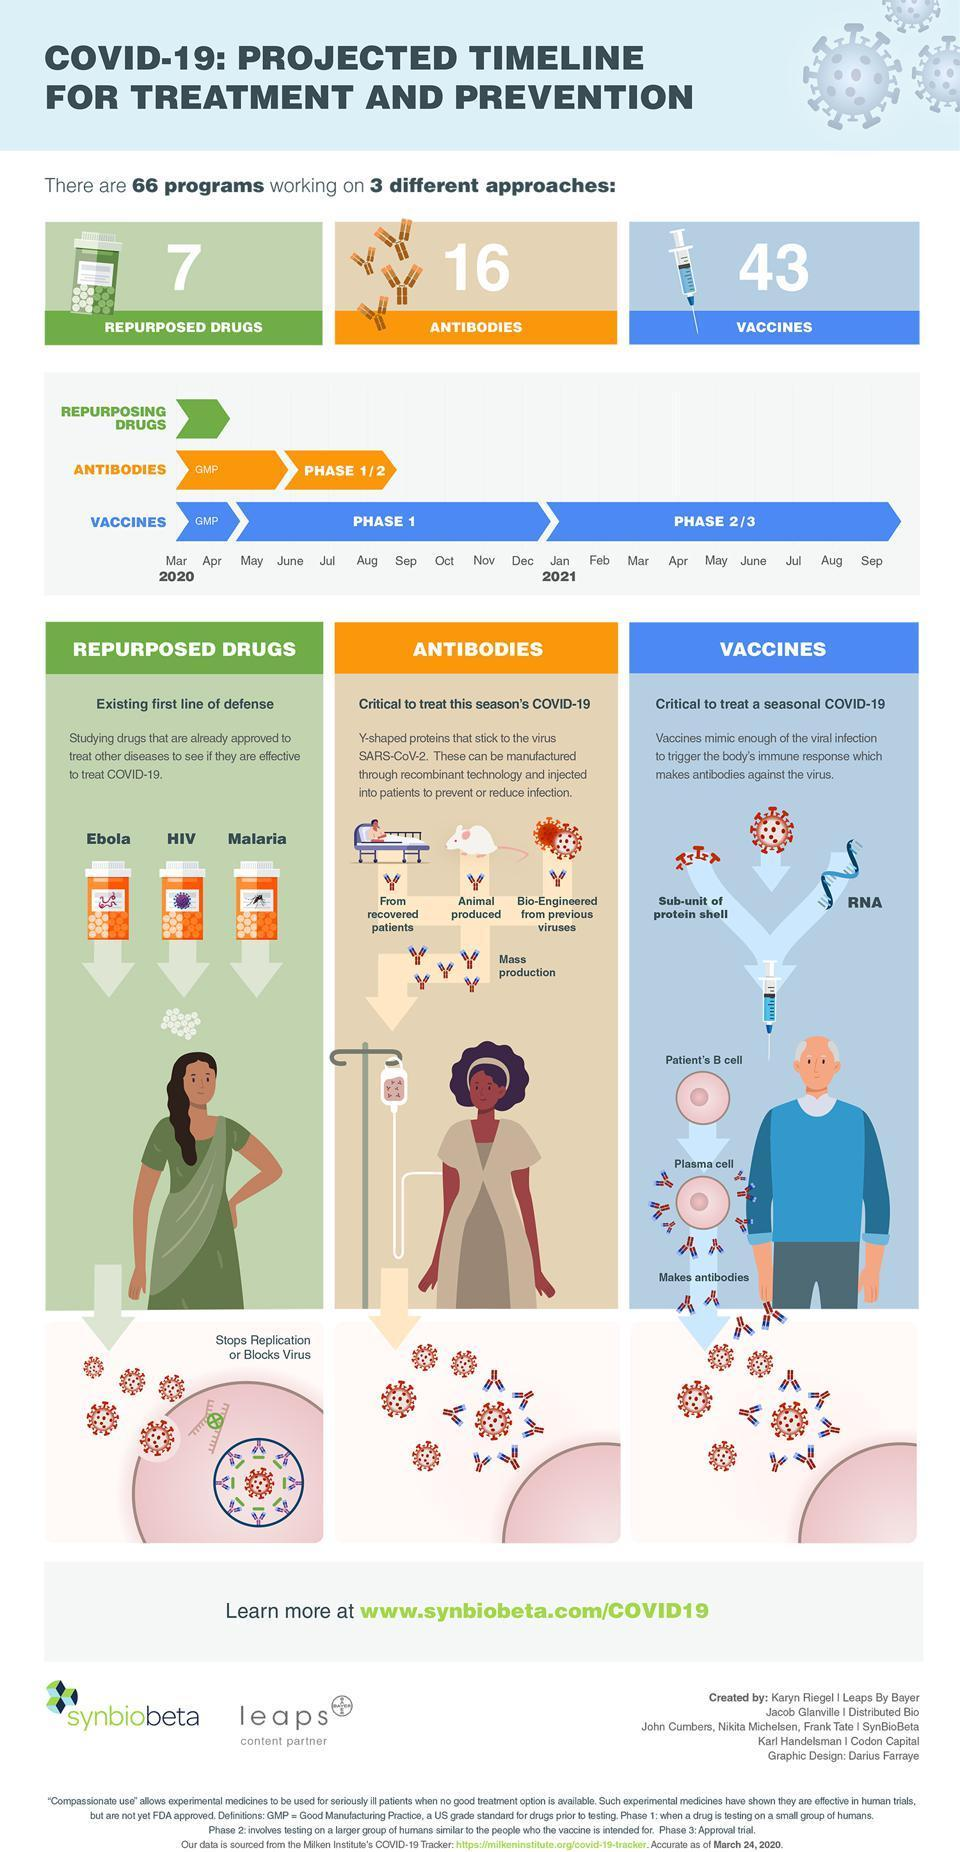What is the contribution of repurposed drugs in programs to prevent or reduce corona?
Answer the question with a short phrase. 7 How many vaccine based approaches are being done to treat corona? 43 By which month vaccine approach started the phase 2/3? Jan In how many different ways Y-shaped proteins can be developed through recombinant technology? 3 Which are the viral diseases that are similar to corona? Ebola, HIV, Malaria Which are the three different approaches to treat and prevent Covid-19? Repurposed Drugs, Antibodies, Vaccines Which part of the body produces antibodies? Plasma cell When did the vaccine approach passed the Phase 1? Dec What is the method used to develop Y-shaped proteins ? recombinant technology How many Antibody based approaches are being done to treat corona? 16 